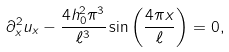<formula> <loc_0><loc_0><loc_500><loc_500>\partial _ { x } ^ { 2 } u _ { x } - \frac { 4 h _ { 0 } ^ { 2 } \pi ^ { 3 } } { \ell ^ { 3 } } \sin \left ( \frac { 4 \pi x } { \ell } \right ) = 0 , \\</formula> 